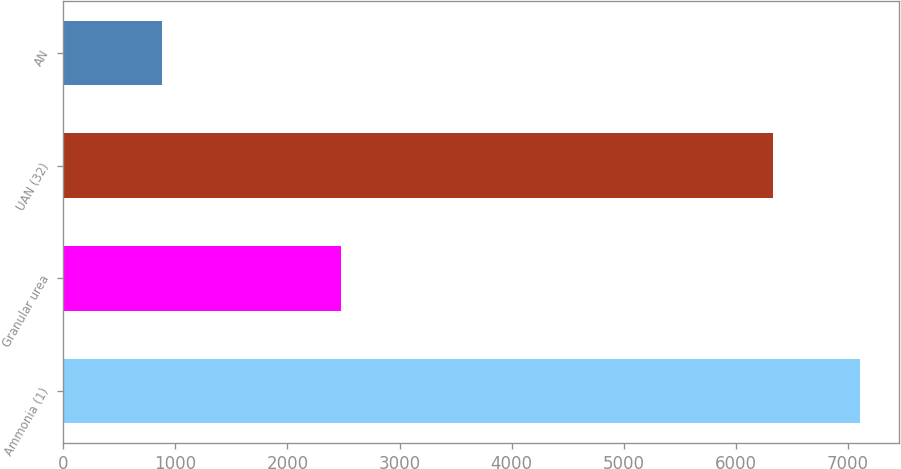<chart> <loc_0><loc_0><loc_500><loc_500><bar_chart><fcel>Ammonia (1)<fcel>Granular urea<fcel>UAN (32)<fcel>AN<nl><fcel>7105<fcel>2474<fcel>6332<fcel>882<nl></chart> 